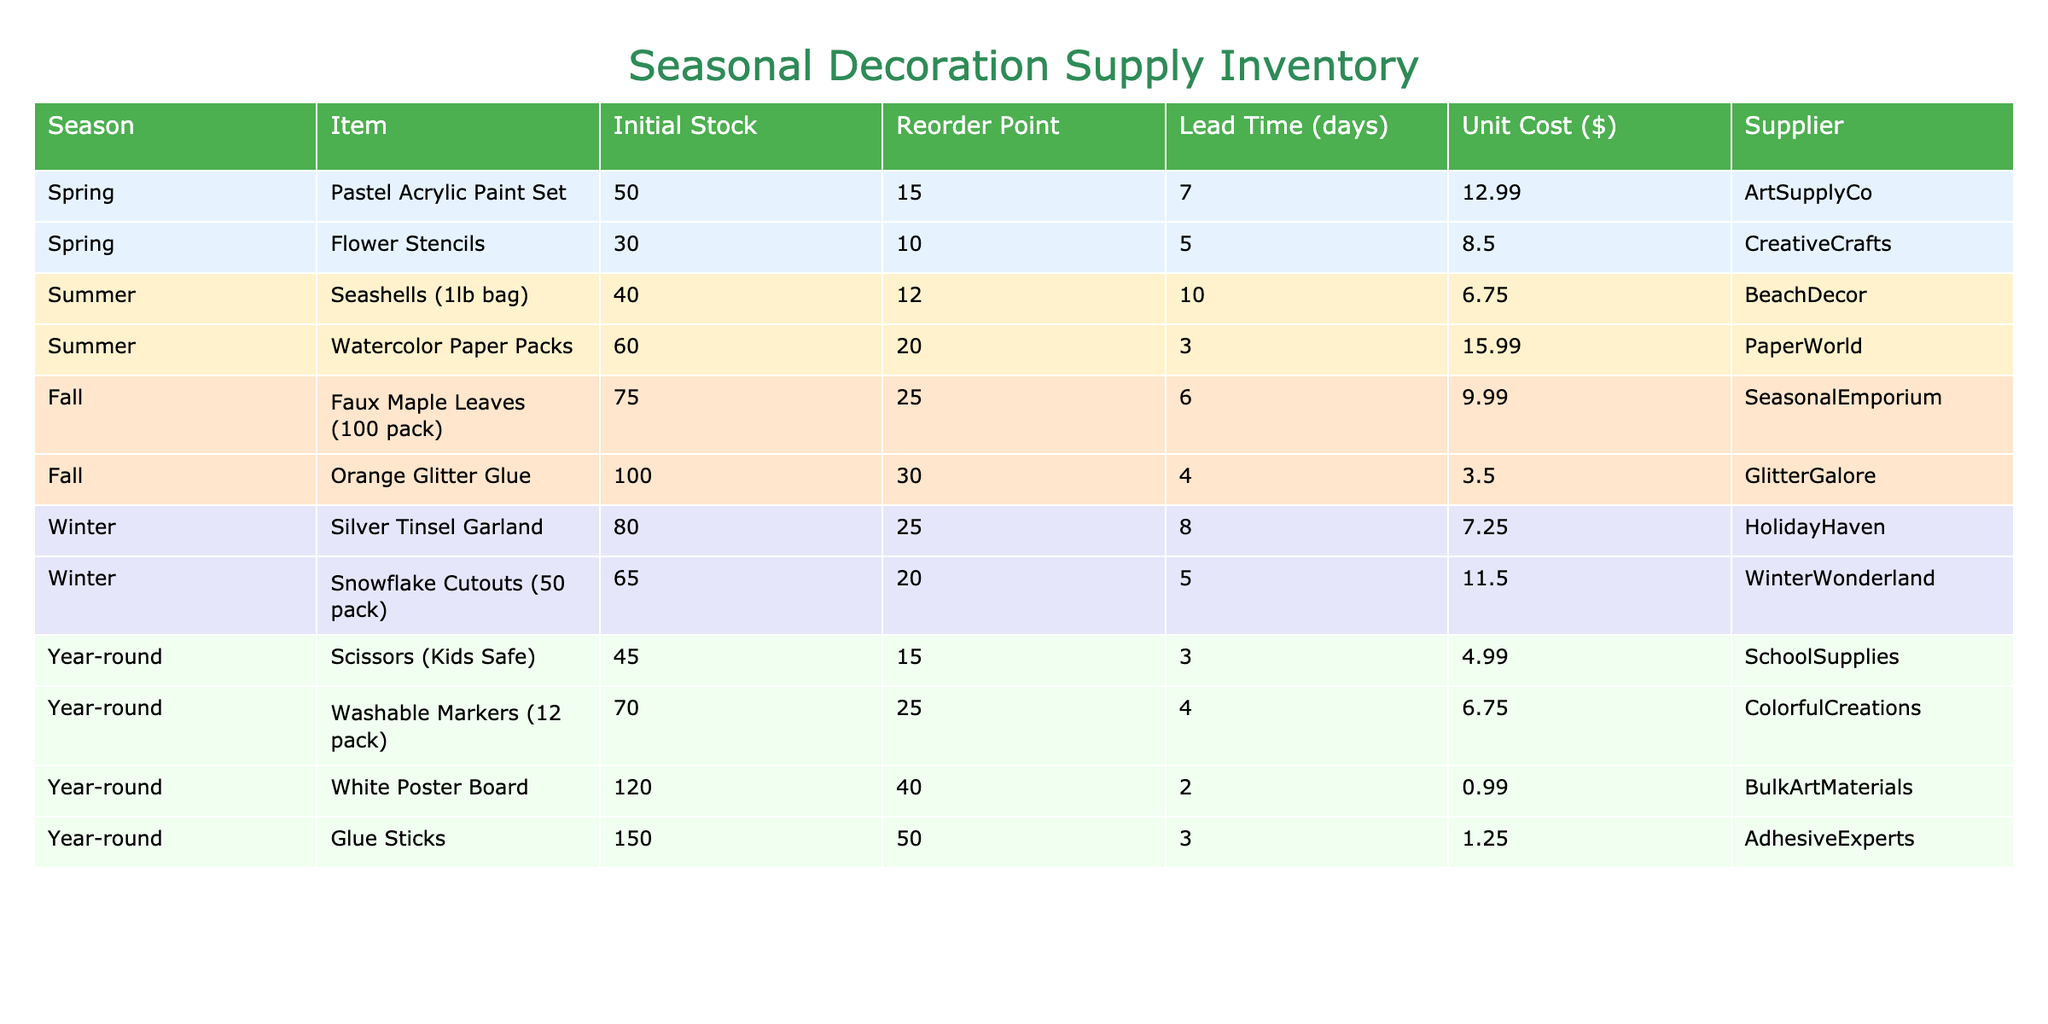What is the initial stock of the Flower Stencils? The initial stock for the Flower Stencils is directly mentioned in the table under the "Initial Stock" column in the row corresponding to "Flower Stencils." The value is 30.
Answer: 30 How many items have a reorder point of 25? By scanning the "Reorder Point" column, I can see that "Watercolor Paper Packs," "Faux Maple Leaves," "Silver Tinsel Garland," and "Washable Markers" all have a reorder point of 25. Counting these gives a total of 4 items.
Answer: 4 Is the cost of the Orange Glitter Glue less than $4? I need to check the "Unit Cost" for the Orange Glitter Glue, which is listed as $3.50. Since $3.50 is indeed less than $4, the answer is yes.
Answer: Yes What items have a lead time of 5 days or fewer? I will refer to the "Lead Time" column and check for values less than or equal to 5. "Flower Stencils," "Orange Glitter Glue," and "Snowflake Cutouts" all have lead times of 5 days or fewer. Counting these gives a total of 3 items.
Answer: 3 What is the total cost of the initial stock for seasonal decorations? To find the total cost, I calculate the cost of each item's initial stock by multiplying the "Initial Stock" by the "Unit Cost" for each item and then summing all those values. Total = (50*12.99) + (30*8.50) + (40*6.75) + (60*15.99) + (75*9.99) + (100*3.50) + (80*7.25) + (65*11.50) = 649.50 + 255 + 270 + 959.40 + 749.25 + 350 + 580 + 747.50 = 3951.65.
Answer: $3951.65 Does the Year-round category have the highest initial stock among all categories? I compare the initial stock from each seasonal category: Spring (50), Summer (60), Fall (75), Winter (80), and Year-round (150). Year-round has the highest initial stock of 150. Thus, the answer is yes.
Answer: Yes What is the average unit cost of items in the Fall season? I first identify the items in the Fall season: "Faux Maple Leaves" ($9.99) and "Orange Glitter Glue" ($3.50). Next, I find the average unit cost by summing those costs ($9.99 + $3.50 = $13.49) and then dividing by the number of items (2). Average cost = $13.49 / 2 = $6.745.
Answer: $6.75 Which item has the highest lead time, and how many days is it? By examining the "Lead Time (days)" column, I find that "Watercolor Paper Packs" have the highest lead time listed as 10 days. Therefore, the item with the highest lead time is "Watercolor Paper Packs" with 10 days.
Answer: Watercolor Paper Packs, 10 days How many supplies have an initial stock greater than 75? Scanning the "Initial Stock" column, I note that the items "Orange Glitter Glue," "Faux Maple Leaves," "Silver Tinsel Garland," "Glue Sticks," and "White Poster Board" have amounts greater than 75. Counting these gives a total of 5 supplies.
Answer: 5 What is the total initial stock for items available in Winter? I refer to the Winter items in the "Initial Stock" column: "Silver Tinsel Garland" (80) and "Snowflake Cutouts" (65). Summing these values gives 80 + 65 = 145.
Answer: 145 